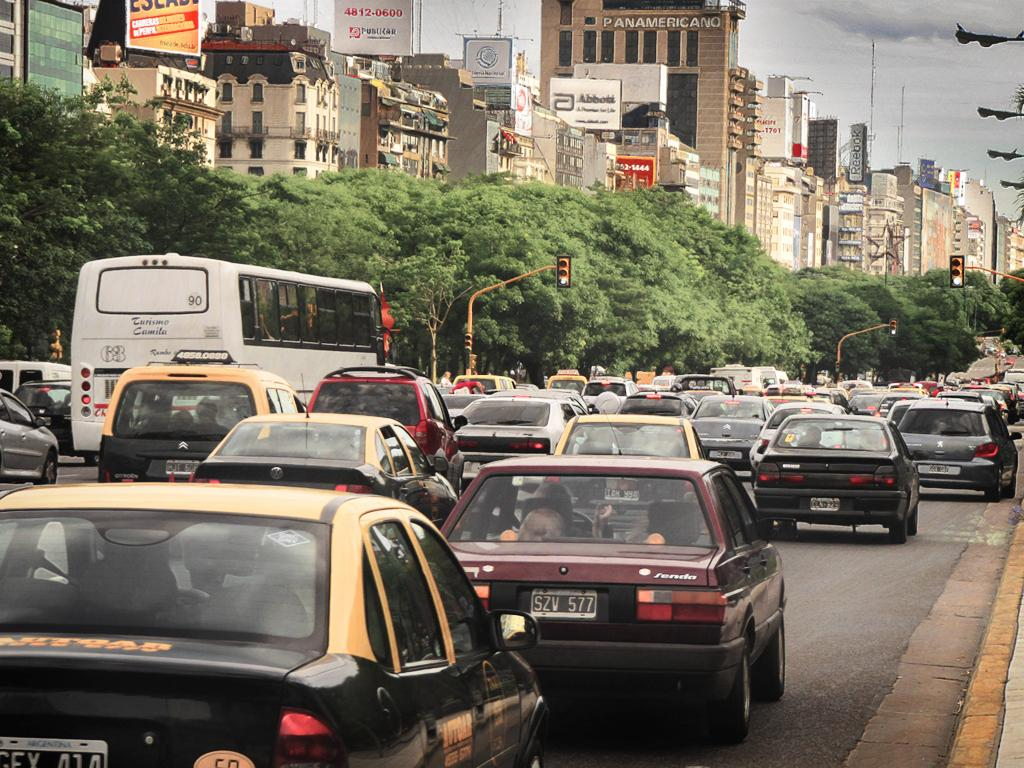<image>
Share a concise interpretation of the image provided. A brownish red car with plate SZV heads down the busy street. 